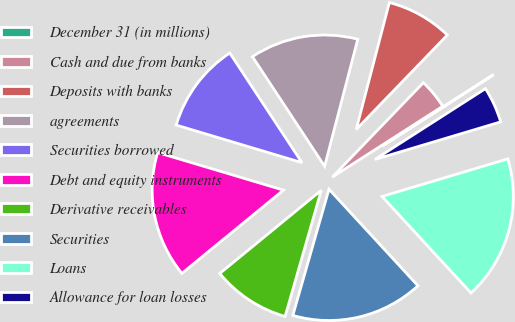<chart> <loc_0><loc_0><loc_500><loc_500><pie_chart><fcel>December 31 (in millions)<fcel>Cash and due from banks<fcel>Deposits with banks<fcel>agreements<fcel>Securities borrowed<fcel>Debt and equity instruments<fcel>Derivative receivables<fcel>Securities<fcel>Loans<fcel>Allowance for loan losses<nl><fcel>0.01%<fcel>3.71%<fcel>8.15%<fcel>13.33%<fcel>11.11%<fcel>15.55%<fcel>9.63%<fcel>16.29%<fcel>17.77%<fcel>4.45%<nl></chart> 